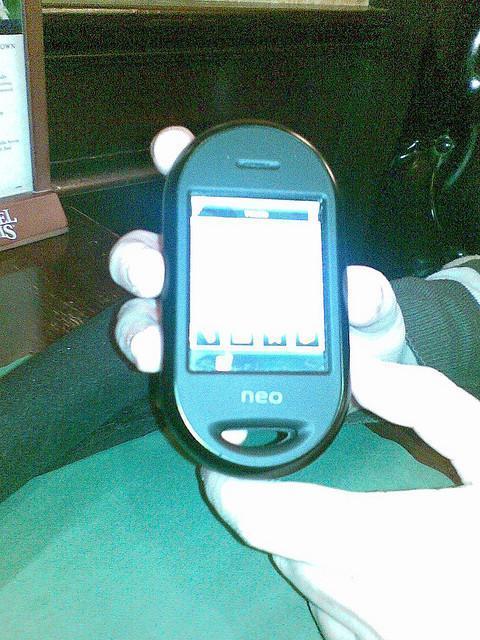How many telephones are here?
Give a very brief answer. 1. How many people are there?
Give a very brief answer. 1. 